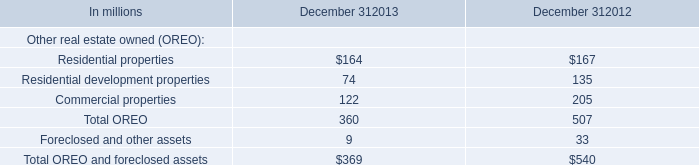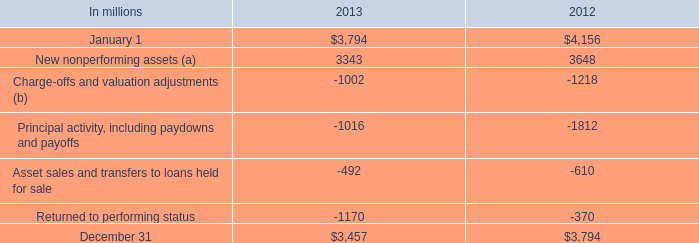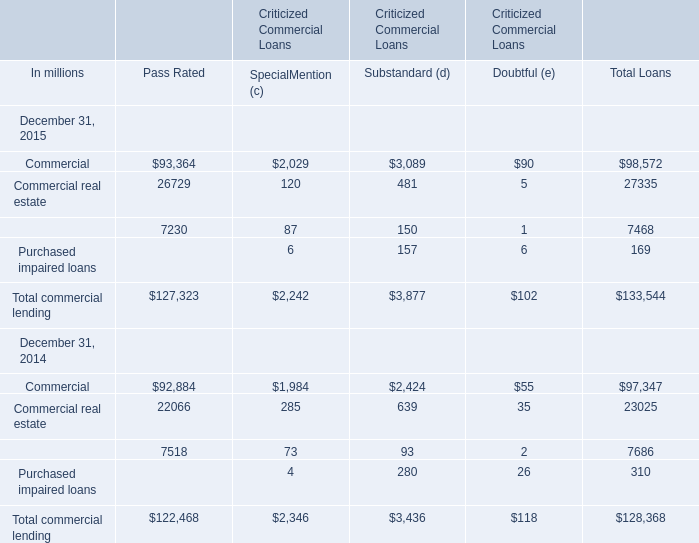What's the average of total commercial lending in 2015 for total loans? (in million) 
Computations: (133544 / 4)
Answer: 33386.0. 